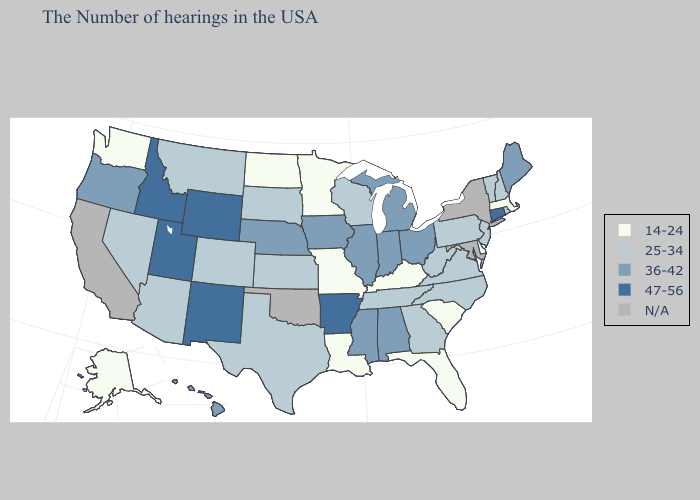Which states have the lowest value in the West?
Keep it brief. Washington, Alaska. Among the states that border Louisiana , which have the highest value?
Give a very brief answer. Arkansas. What is the highest value in the USA?
Short answer required. 47-56. What is the highest value in the Northeast ?
Be succinct. 47-56. Which states have the highest value in the USA?
Quick response, please. Connecticut, Arkansas, Wyoming, New Mexico, Utah, Idaho. Among the states that border Wisconsin , does Minnesota have the highest value?
Be succinct. No. Name the states that have a value in the range 25-34?
Short answer required. Rhode Island, New Hampshire, Vermont, New Jersey, Pennsylvania, Virginia, North Carolina, West Virginia, Georgia, Tennessee, Wisconsin, Kansas, Texas, South Dakota, Colorado, Montana, Arizona, Nevada. What is the value of Vermont?
Short answer required. 25-34. Name the states that have a value in the range 47-56?
Concise answer only. Connecticut, Arkansas, Wyoming, New Mexico, Utah, Idaho. What is the value of Rhode Island?
Give a very brief answer. 25-34. Name the states that have a value in the range 25-34?
Be succinct. Rhode Island, New Hampshire, Vermont, New Jersey, Pennsylvania, Virginia, North Carolina, West Virginia, Georgia, Tennessee, Wisconsin, Kansas, Texas, South Dakota, Colorado, Montana, Arizona, Nevada. Does the map have missing data?
Quick response, please. Yes. Does Virginia have the highest value in the South?
Answer briefly. No. 